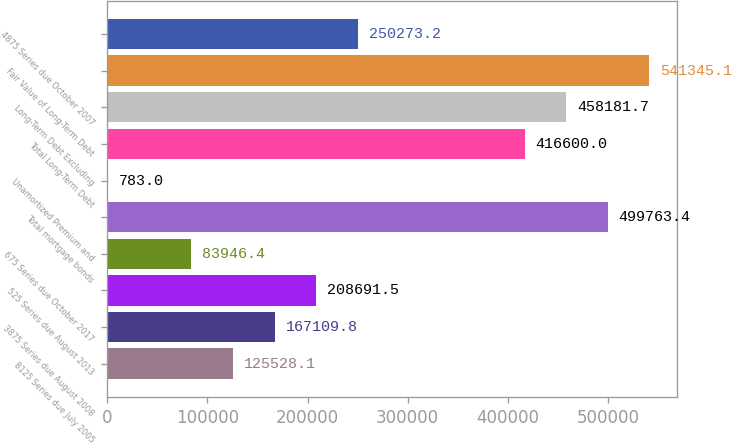Convert chart to OTSL. <chart><loc_0><loc_0><loc_500><loc_500><bar_chart><fcel>8125 Series due July 2005<fcel>3875 Series due August 2008<fcel>525 Series due August 2013<fcel>675 Series due October 2017<fcel>Total mortgage bonds<fcel>Unamortized Premium and<fcel>Total Long-Term Debt<fcel>Long-Term Debt Excluding<fcel>Fair Value of Long-Term Debt<fcel>4875 Series due October 2007<nl><fcel>125528<fcel>167110<fcel>208692<fcel>83946.4<fcel>499763<fcel>783<fcel>416600<fcel>458182<fcel>541345<fcel>250273<nl></chart> 